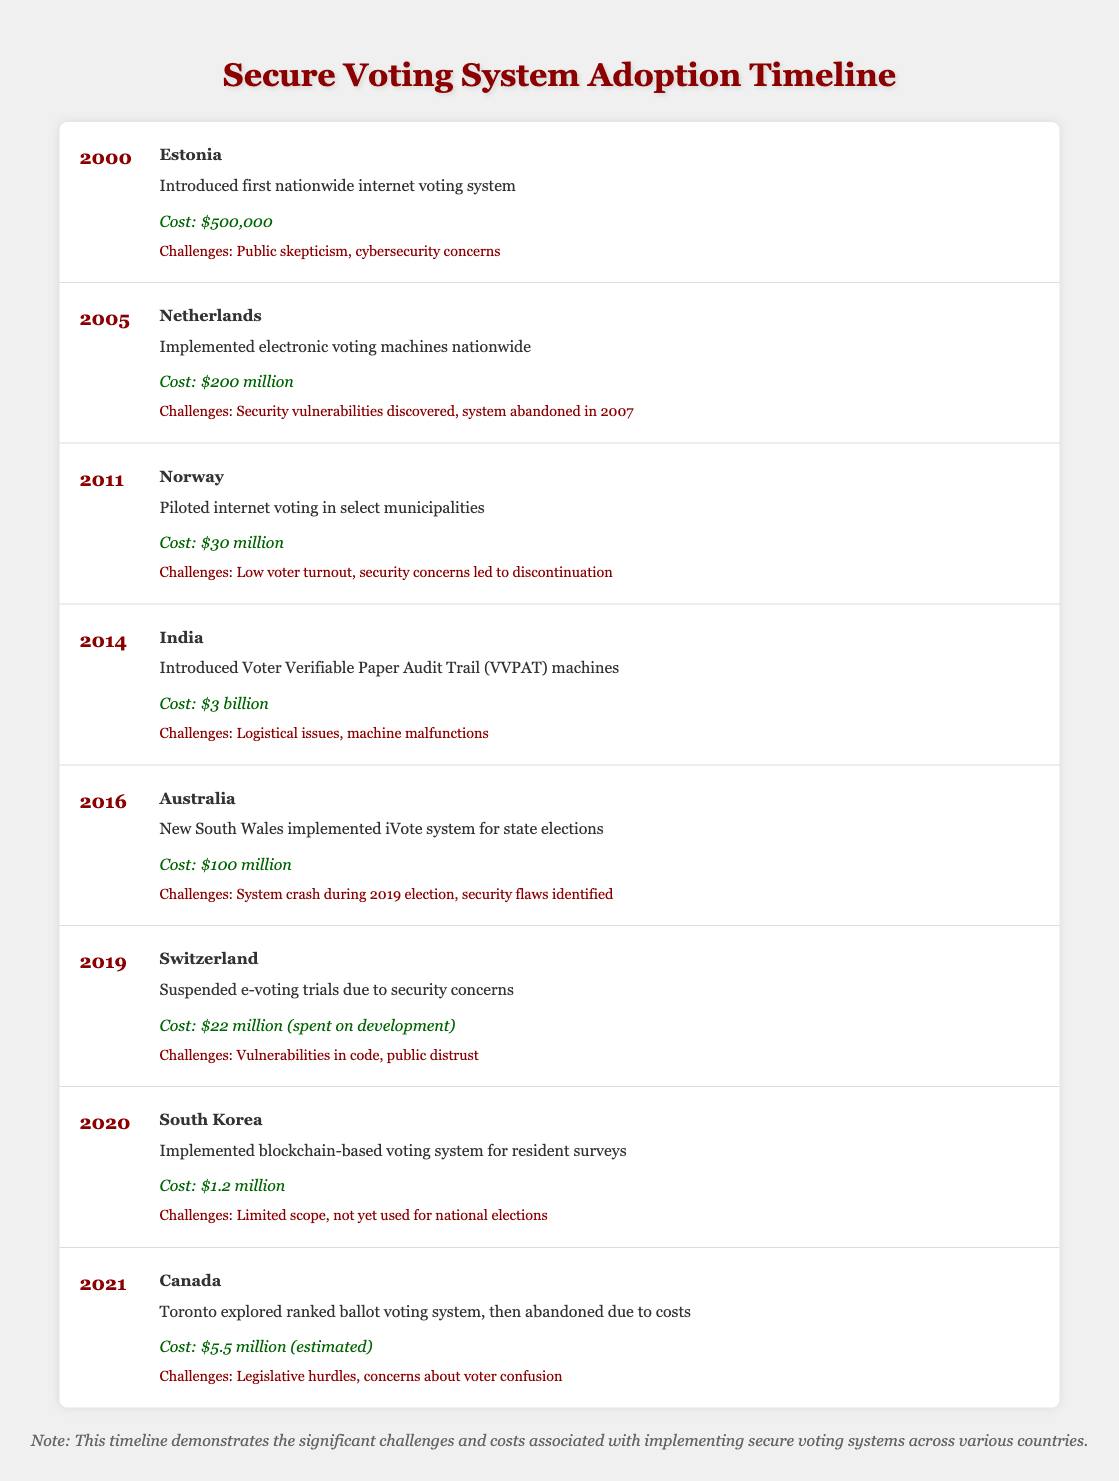What year did Estonia introduce its internet voting system? We look at the table and find that Estonia introduced its internet voting system in 2000.
Answer: 2000 What was the cost of the electronic voting machines implemented in the Netherlands? The table indicates that the cost of the electronic voting machines implemented in the Netherlands in 2005 was $200 million.
Answer: $200 million Did Norway continue its internet voting after the pilot in 2011? According to the table, Norway piloted internet voting in 2011, but it was discontinued due to low voter turnout and security concerns. Therefore, the answer is no.
Answer: No What is the total cost of the voting systems introduced by India and Australia? From the table, India's voting system cost $3 billion and Australia's cost was $100 million. Adding these two amounts gives 3 billion + 0.1 billion = 3.1 billion.
Answer: $3.1 billion Which country suspended its e-voting trials due to security concerns, and what was the cost of development? The table shows that Switzerland suspended its e-voting trials in 2019 due to security concerns, and the cost spent on development was $22 million.
Answer: Switzerland; $22 million What challenges did Canada face when exploring the ranked ballot voting system in 2021? The table lists the challenges Canada encountered as legislative hurdles and concerns about voter confusion.
Answer: Legislative hurdles, voter confusion What was the average cost of voting systems implemented between 2000 and 2016? Summing the costs from the years 2000 to 2016, we have: $500,000 + $200 million + $30 million + $3 billion + $100 million = $3.33 billion. There are 5 systems, so the average cost is $3.33 billion / 5 = approximately $666 million.
Answer: $666 million What common challenges are noted across different countries' voting system implementations? Reviewing the table, common challenges include public skepticism, security concerns, machine malfunctions, and public distrust, as noted in multiple rows.
Answer: Public skepticism, security concerns, machine malfunctions, public distrust 